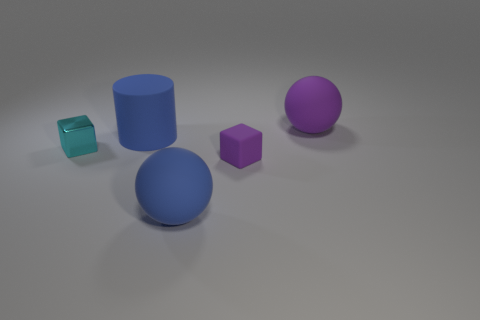Add 3 cylinders. How many objects exist? 8 Subtract all cylinders. How many objects are left? 4 Add 5 big blue matte cylinders. How many big blue matte cylinders are left? 6 Add 5 cubes. How many cubes exist? 7 Subtract 1 purple cubes. How many objects are left? 4 Subtract all green cubes. Subtract all brown spheres. How many cubes are left? 2 Subtract all red cylinders. How many blue blocks are left? 0 Subtract all purple shiny cubes. Subtract all tiny blocks. How many objects are left? 3 